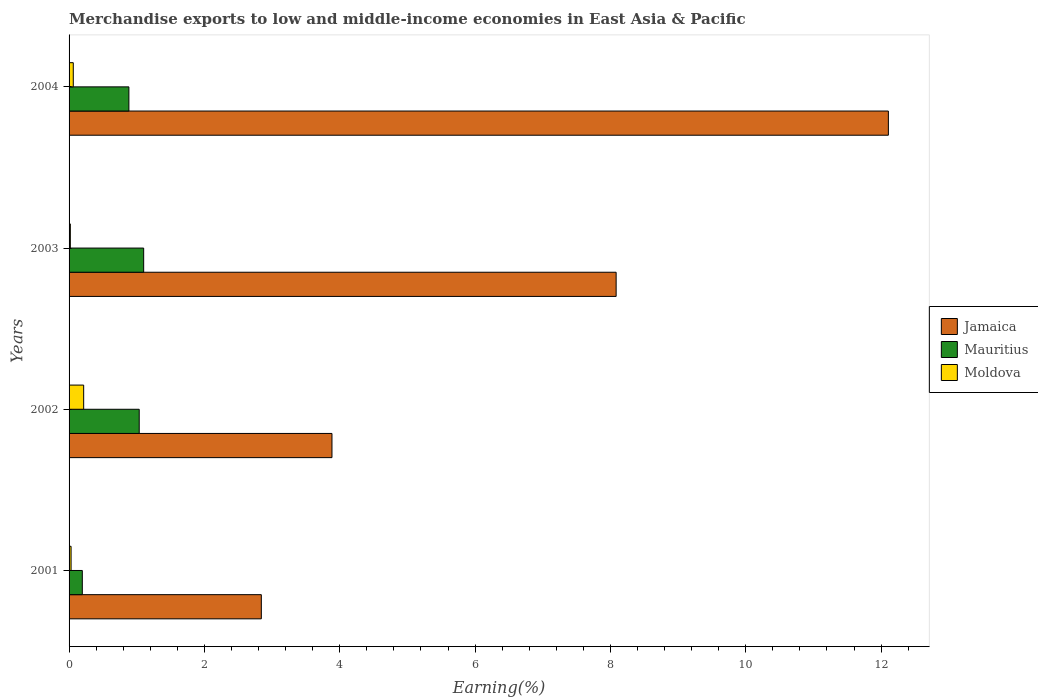Are the number of bars per tick equal to the number of legend labels?
Your response must be concise. Yes. Are the number of bars on each tick of the Y-axis equal?
Keep it short and to the point. Yes. How many bars are there on the 1st tick from the bottom?
Give a very brief answer. 3. What is the label of the 3rd group of bars from the top?
Your answer should be very brief. 2002. In how many cases, is the number of bars for a given year not equal to the number of legend labels?
Ensure brevity in your answer.  0. What is the percentage of amount earned from merchandise exports in Mauritius in 2003?
Your answer should be compact. 1.1. Across all years, what is the maximum percentage of amount earned from merchandise exports in Mauritius?
Make the answer very short. 1.1. Across all years, what is the minimum percentage of amount earned from merchandise exports in Jamaica?
Keep it short and to the point. 2.84. In which year was the percentage of amount earned from merchandise exports in Mauritius maximum?
Provide a succinct answer. 2003. In which year was the percentage of amount earned from merchandise exports in Moldova minimum?
Your response must be concise. 2003. What is the total percentage of amount earned from merchandise exports in Jamaica in the graph?
Offer a very short reply. 26.92. What is the difference between the percentage of amount earned from merchandise exports in Mauritius in 2001 and that in 2003?
Keep it short and to the point. -0.91. What is the difference between the percentage of amount earned from merchandise exports in Moldova in 2004 and the percentage of amount earned from merchandise exports in Mauritius in 2002?
Make the answer very short. -0.97. What is the average percentage of amount earned from merchandise exports in Mauritius per year?
Provide a short and direct response. 0.8. In the year 2004, what is the difference between the percentage of amount earned from merchandise exports in Moldova and percentage of amount earned from merchandise exports in Jamaica?
Your response must be concise. -12.05. What is the ratio of the percentage of amount earned from merchandise exports in Mauritius in 2003 to that in 2004?
Provide a short and direct response. 1.25. Is the percentage of amount earned from merchandise exports in Mauritius in 2001 less than that in 2002?
Provide a succinct answer. Yes. What is the difference between the highest and the second highest percentage of amount earned from merchandise exports in Moldova?
Give a very brief answer. 0.15. What is the difference between the highest and the lowest percentage of amount earned from merchandise exports in Jamaica?
Make the answer very short. 9.27. What does the 1st bar from the top in 2003 represents?
Offer a terse response. Moldova. What does the 2nd bar from the bottom in 2001 represents?
Offer a terse response. Mauritius. Is it the case that in every year, the sum of the percentage of amount earned from merchandise exports in Moldova and percentage of amount earned from merchandise exports in Jamaica is greater than the percentage of amount earned from merchandise exports in Mauritius?
Your response must be concise. Yes. How many years are there in the graph?
Provide a succinct answer. 4. What is the difference between two consecutive major ticks on the X-axis?
Your answer should be very brief. 2. Where does the legend appear in the graph?
Your answer should be very brief. Center right. How are the legend labels stacked?
Your answer should be very brief. Vertical. What is the title of the graph?
Provide a short and direct response. Merchandise exports to low and middle-income economies in East Asia & Pacific. What is the label or title of the X-axis?
Make the answer very short. Earning(%). What is the label or title of the Y-axis?
Your answer should be compact. Years. What is the Earning(%) in Jamaica in 2001?
Your answer should be very brief. 2.84. What is the Earning(%) of Mauritius in 2001?
Keep it short and to the point. 0.2. What is the Earning(%) in Moldova in 2001?
Give a very brief answer. 0.03. What is the Earning(%) of Jamaica in 2002?
Offer a terse response. 3.89. What is the Earning(%) of Mauritius in 2002?
Your response must be concise. 1.04. What is the Earning(%) in Moldova in 2002?
Keep it short and to the point. 0.22. What is the Earning(%) in Jamaica in 2003?
Your response must be concise. 8.08. What is the Earning(%) in Mauritius in 2003?
Your answer should be very brief. 1.1. What is the Earning(%) of Moldova in 2003?
Your response must be concise. 0.02. What is the Earning(%) of Jamaica in 2004?
Your answer should be compact. 12.11. What is the Earning(%) of Mauritius in 2004?
Provide a succinct answer. 0.88. What is the Earning(%) of Moldova in 2004?
Your response must be concise. 0.06. Across all years, what is the maximum Earning(%) in Jamaica?
Provide a succinct answer. 12.11. Across all years, what is the maximum Earning(%) in Mauritius?
Keep it short and to the point. 1.1. Across all years, what is the maximum Earning(%) of Moldova?
Make the answer very short. 0.22. Across all years, what is the minimum Earning(%) of Jamaica?
Provide a succinct answer. 2.84. Across all years, what is the minimum Earning(%) in Mauritius?
Provide a succinct answer. 0.2. Across all years, what is the minimum Earning(%) in Moldova?
Offer a very short reply. 0.02. What is the total Earning(%) in Jamaica in the graph?
Ensure brevity in your answer.  26.92. What is the total Earning(%) in Mauritius in the graph?
Ensure brevity in your answer.  3.22. What is the total Earning(%) in Moldova in the graph?
Make the answer very short. 0.33. What is the difference between the Earning(%) of Jamaica in 2001 and that in 2002?
Keep it short and to the point. -1.04. What is the difference between the Earning(%) of Mauritius in 2001 and that in 2002?
Provide a succinct answer. -0.84. What is the difference between the Earning(%) of Moldova in 2001 and that in 2002?
Provide a succinct answer. -0.19. What is the difference between the Earning(%) of Jamaica in 2001 and that in 2003?
Your answer should be very brief. -5.24. What is the difference between the Earning(%) in Mauritius in 2001 and that in 2003?
Offer a very short reply. -0.91. What is the difference between the Earning(%) in Moldova in 2001 and that in 2003?
Provide a succinct answer. 0.01. What is the difference between the Earning(%) of Jamaica in 2001 and that in 2004?
Your answer should be compact. -9.27. What is the difference between the Earning(%) in Mauritius in 2001 and that in 2004?
Your answer should be very brief. -0.69. What is the difference between the Earning(%) in Moldova in 2001 and that in 2004?
Ensure brevity in your answer.  -0.03. What is the difference between the Earning(%) of Jamaica in 2002 and that in 2003?
Ensure brevity in your answer.  -4.2. What is the difference between the Earning(%) in Mauritius in 2002 and that in 2003?
Make the answer very short. -0.07. What is the difference between the Earning(%) of Moldova in 2002 and that in 2003?
Offer a very short reply. 0.2. What is the difference between the Earning(%) of Jamaica in 2002 and that in 2004?
Keep it short and to the point. -8.22. What is the difference between the Earning(%) of Mauritius in 2002 and that in 2004?
Provide a succinct answer. 0.15. What is the difference between the Earning(%) in Moldova in 2002 and that in 2004?
Offer a very short reply. 0.15. What is the difference between the Earning(%) of Jamaica in 2003 and that in 2004?
Your answer should be compact. -4.02. What is the difference between the Earning(%) of Mauritius in 2003 and that in 2004?
Your answer should be compact. 0.22. What is the difference between the Earning(%) in Moldova in 2003 and that in 2004?
Your response must be concise. -0.04. What is the difference between the Earning(%) in Jamaica in 2001 and the Earning(%) in Mauritius in 2002?
Provide a succinct answer. 1.8. What is the difference between the Earning(%) in Jamaica in 2001 and the Earning(%) in Moldova in 2002?
Ensure brevity in your answer.  2.63. What is the difference between the Earning(%) in Mauritius in 2001 and the Earning(%) in Moldova in 2002?
Provide a short and direct response. -0.02. What is the difference between the Earning(%) in Jamaica in 2001 and the Earning(%) in Mauritius in 2003?
Give a very brief answer. 1.74. What is the difference between the Earning(%) of Jamaica in 2001 and the Earning(%) of Moldova in 2003?
Offer a terse response. 2.82. What is the difference between the Earning(%) in Mauritius in 2001 and the Earning(%) in Moldova in 2003?
Make the answer very short. 0.18. What is the difference between the Earning(%) of Jamaica in 2001 and the Earning(%) of Mauritius in 2004?
Your answer should be very brief. 1.96. What is the difference between the Earning(%) of Jamaica in 2001 and the Earning(%) of Moldova in 2004?
Make the answer very short. 2.78. What is the difference between the Earning(%) in Mauritius in 2001 and the Earning(%) in Moldova in 2004?
Provide a succinct answer. 0.13. What is the difference between the Earning(%) in Jamaica in 2002 and the Earning(%) in Mauritius in 2003?
Ensure brevity in your answer.  2.78. What is the difference between the Earning(%) of Jamaica in 2002 and the Earning(%) of Moldova in 2003?
Give a very brief answer. 3.87. What is the difference between the Earning(%) in Mauritius in 2002 and the Earning(%) in Moldova in 2003?
Offer a very short reply. 1.02. What is the difference between the Earning(%) of Jamaica in 2002 and the Earning(%) of Mauritius in 2004?
Your answer should be very brief. 3. What is the difference between the Earning(%) in Jamaica in 2002 and the Earning(%) in Moldova in 2004?
Make the answer very short. 3.82. What is the difference between the Earning(%) of Mauritius in 2002 and the Earning(%) of Moldova in 2004?
Your answer should be compact. 0.97. What is the difference between the Earning(%) in Jamaica in 2003 and the Earning(%) in Mauritius in 2004?
Your response must be concise. 7.2. What is the difference between the Earning(%) of Jamaica in 2003 and the Earning(%) of Moldova in 2004?
Ensure brevity in your answer.  8.02. What is the difference between the Earning(%) of Mauritius in 2003 and the Earning(%) of Moldova in 2004?
Offer a terse response. 1.04. What is the average Earning(%) in Jamaica per year?
Offer a very short reply. 6.73. What is the average Earning(%) in Mauritius per year?
Offer a very short reply. 0.8. What is the average Earning(%) of Moldova per year?
Provide a succinct answer. 0.08. In the year 2001, what is the difference between the Earning(%) in Jamaica and Earning(%) in Mauritius?
Provide a succinct answer. 2.65. In the year 2001, what is the difference between the Earning(%) of Jamaica and Earning(%) of Moldova?
Offer a terse response. 2.81. In the year 2001, what is the difference between the Earning(%) of Mauritius and Earning(%) of Moldova?
Make the answer very short. 0.17. In the year 2002, what is the difference between the Earning(%) of Jamaica and Earning(%) of Mauritius?
Keep it short and to the point. 2.85. In the year 2002, what is the difference between the Earning(%) of Jamaica and Earning(%) of Moldova?
Your answer should be very brief. 3.67. In the year 2002, what is the difference between the Earning(%) in Mauritius and Earning(%) in Moldova?
Offer a very short reply. 0.82. In the year 2003, what is the difference between the Earning(%) of Jamaica and Earning(%) of Mauritius?
Your answer should be compact. 6.98. In the year 2003, what is the difference between the Earning(%) of Jamaica and Earning(%) of Moldova?
Your answer should be very brief. 8.07. In the year 2003, what is the difference between the Earning(%) of Mauritius and Earning(%) of Moldova?
Offer a terse response. 1.08. In the year 2004, what is the difference between the Earning(%) in Jamaica and Earning(%) in Mauritius?
Ensure brevity in your answer.  11.22. In the year 2004, what is the difference between the Earning(%) in Jamaica and Earning(%) in Moldova?
Your response must be concise. 12.05. In the year 2004, what is the difference between the Earning(%) of Mauritius and Earning(%) of Moldova?
Offer a terse response. 0.82. What is the ratio of the Earning(%) of Jamaica in 2001 to that in 2002?
Make the answer very short. 0.73. What is the ratio of the Earning(%) of Mauritius in 2001 to that in 2002?
Provide a succinct answer. 0.19. What is the ratio of the Earning(%) in Moldova in 2001 to that in 2002?
Ensure brevity in your answer.  0.14. What is the ratio of the Earning(%) of Jamaica in 2001 to that in 2003?
Provide a succinct answer. 0.35. What is the ratio of the Earning(%) of Mauritius in 2001 to that in 2003?
Provide a short and direct response. 0.18. What is the ratio of the Earning(%) in Moldova in 2001 to that in 2003?
Ensure brevity in your answer.  1.58. What is the ratio of the Earning(%) in Jamaica in 2001 to that in 2004?
Keep it short and to the point. 0.23. What is the ratio of the Earning(%) in Mauritius in 2001 to that in 2004?
Ensure brevity in your answer.  0.22. What is the ratio of the Earning(%) in Moldova in 2001 to that in 2004?
Offer a terse response. 0.48. What is the ratio of the Earning(%) of Jamaica in 2002 to that in 2003?
Offer a terse response. 0.48. What is the ratio of the Earning(%) of Mauritius in 2002 to that in 2003?
Ensure brevity in your answer.  0.94. What is the ratio of the Earning(%) of Moldova in 2002 to that in 2003?
Offer a very short reply. 11.52. What is the ratio of the Earning(%) of Jamaica in 2002 to that in 2004?
Give a very brief answer. 0.32. What is the ratio of the Earning(%) in Mauritius in 2002 to that in 2004?
Offer a terse response. 1.17. What is the ratio of the Earning(%) of Moldova in 2002 to that in 2004?
Make the answer very short. 3.47. What is the ratio of the Earning(%) in Jamaica in 2003 to that in 2004?
Make the answer very short. 0.67. What is the ratio of the Earning(%) in Mauritius in 2003 to that in 2004?
Provide a succinct answer. 1.25. What is the ratio of the Earning(%) in Moldova in 2003 to that in 2004?
Make the answer very short. 0.3. What is the difference between the highest and the second highest Earning(%) of Jamaica?
Your answer should be very brief. 4.02. What is the difference between the highest and the second highest Earning(%) of Mauritius?
Your answer should be very brief. 0.07. What is the difference between the highest and the second highest Earning(%) of Moldova?
Offer a terse response. 0.15. What is the difference between the highest and the lowest Earning(%) in Jamaica?
Make the answer very short. 9.27. What is the difference between the highest and the lowest Earning(%) in Mauritius?
Your response must be concise. 0.91. What is the difference between the highest and the lowest Earning(%) in Moldova?
Keep it short and to the point. 0.2. 